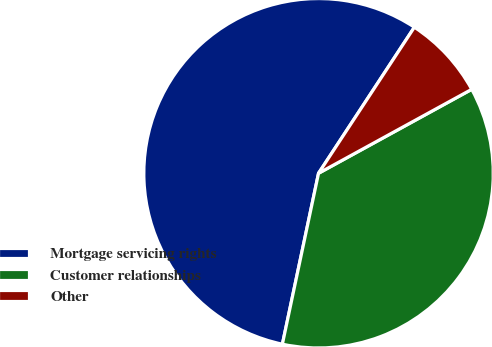<chart> <loc_0><loc_0><loc_500><loc_500><pie_chart><fcel>Mortgage servicing rights<fcel>Customer relationships<fcel>Other<nl><fcel>55.93%<fcel>36.3%<fcel>7.78%<nl></chart> 